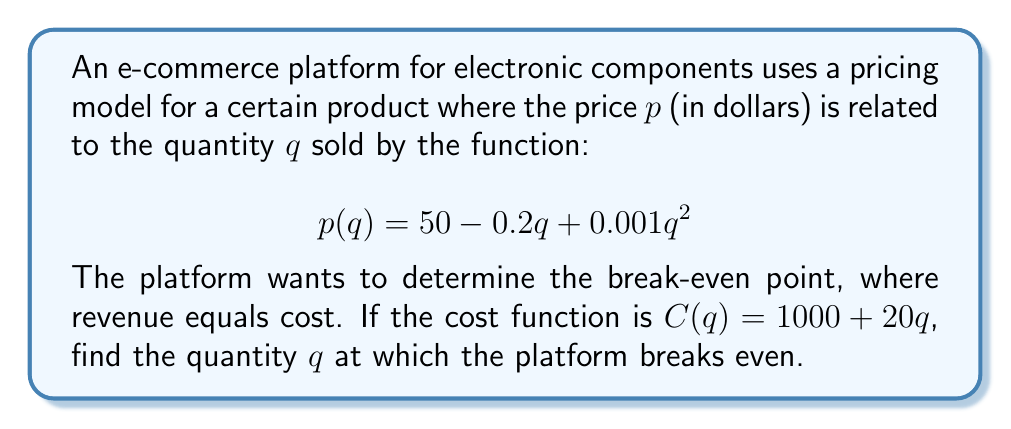Can you answer this question? To solve this problem, we need to follow these steps:

1) First, we need to set up the break-even equation. At the break-even point, revenue equals cost:

   $R(q) = C(q)$

2) Revenue is price times quantity:

   $R(q) = p(q) \cdot q = (50 - 0.2q + 0.001q^2) \cdot q$

3) Expand this:

   $R(q) = 50q - 0.2q^2 + 0.001q^3$

4) Now we can set up our break-even equation:

   $50q - 0.2q^2 + 0.001q^3 = 1000 + 20q$

5) Rearrange the equation:

   $0.001q^3 - 0.2q^2 + 30q - 1000 = 0$

6) This is a cubic equation. It can be solved using the cubic formula or graphing methods. Using a graphing calculator or computer algebra system, we find that this equation has three roots: approximately -146.8, 33.4, and 313.4.

7) Since quantity cannot be negative, and 313.4 is unrealistically large for this scenario, the break-even point occurs at $q \approx 33.4$ units.
Answer: The break-even quantity is approximately 33.4 units. 